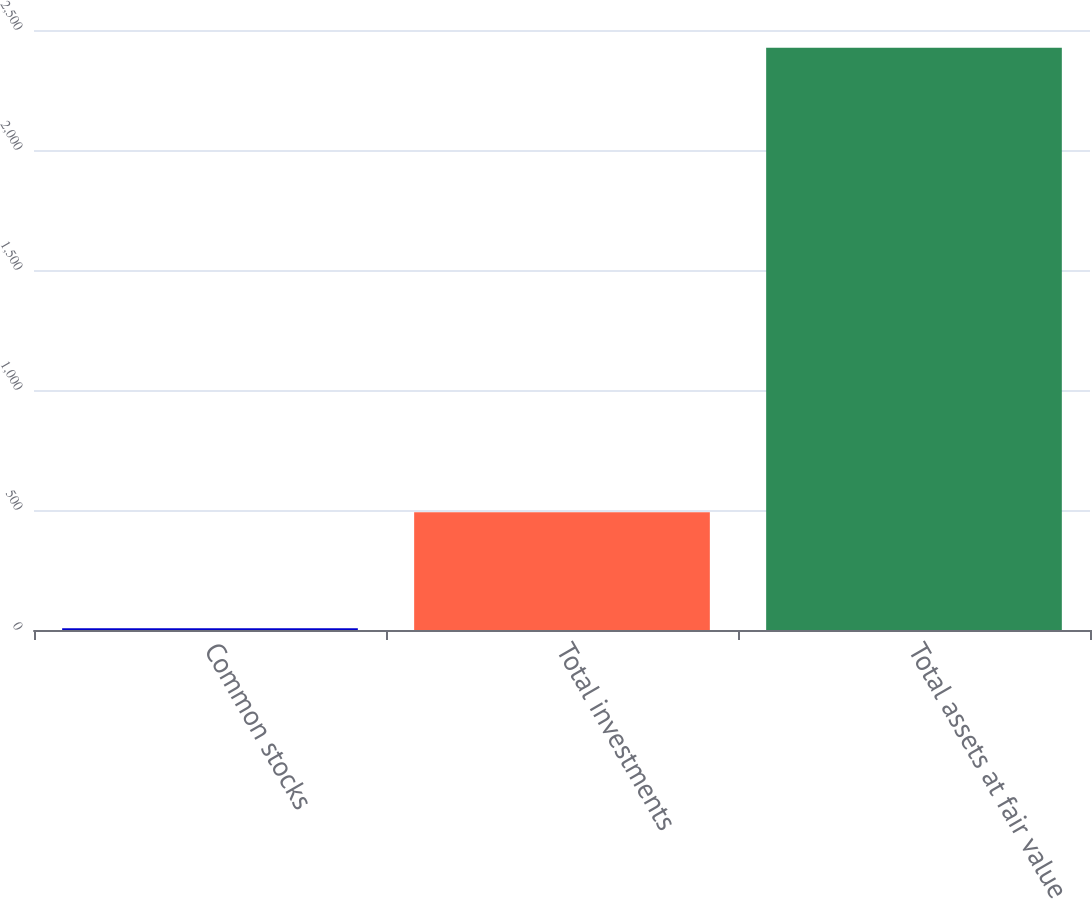Convert chart to OTSL. <chart><loc_0><loc_0><loc_500><loc_500><bar_chart><fcel>Common stocks<fcel>Total investments<fcel>Total assets at fair value<nl><fcel>7<fcel>491<fcel>2426<nl></chart> 